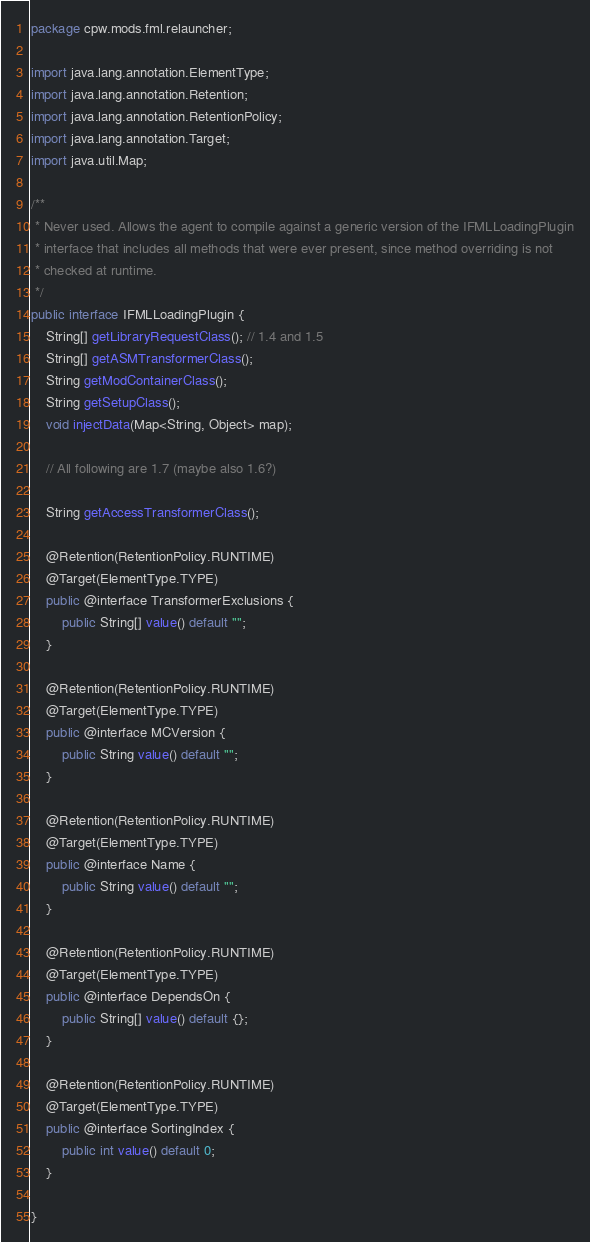Convert code to text. <code><loc_0><loc_0><loc_500><loc_500><_Java_>package cpw.mods.fml.relauncher;

import java.lang.annotation.ElementType;
import java.lang.annotation.Retention;
import java.lang.annotation.RetentionPolicy;
import java.lang.annotation.Target;
import java.util.Map;

/**
 * Never used. Allows the agent to compile against a generic version of the IFMLLoadingPlugin
 * interface that includes all methods that were ever present, since method overriding is not
 * checked at runtime.
 */
public interface IFMLLoadingPlugin {
	String[] getLibraryRequestClass(); // 1.4 and 1.5
	String[] getASMTransformerClass();
	String getModContainerClass();
	String getSetupClass();
	void injectData(Map<String, Object> map);

	// All following are 1.7 (maybe also 1.6?)
	
	String getAccessTransformerClass();
	
	@Retention(RetentionPolicy.RUNTIME)
	@Target(ElementType.TYPE)
	public @interface TransformerExclusions {
		public String[] value() default "";
	}

	@Retention(RetentionPolicy.RUNTIME)
	@Target(ElementType.TYPE)
	public @interface MCVersion {
		public String value() default "";
	}

	@Retention(RetentionPolicy.RUNTIME)
	@Target(ElementType.TYPE)
	public @interface Name {
		public String value() default "";
	}

	@Retention(RetentionPolicy.RUNTIME)
	@Target(ElementType.TYPE)
	public @interface DependsOn {
		public String[] value() default {};
	}

	@Retention(RetentionPolicy.RUNTIME)
	@Target(ElementType.TYPE)
	public @interface SortingIndex {
		public int value() default 0;
	}

}</code> 